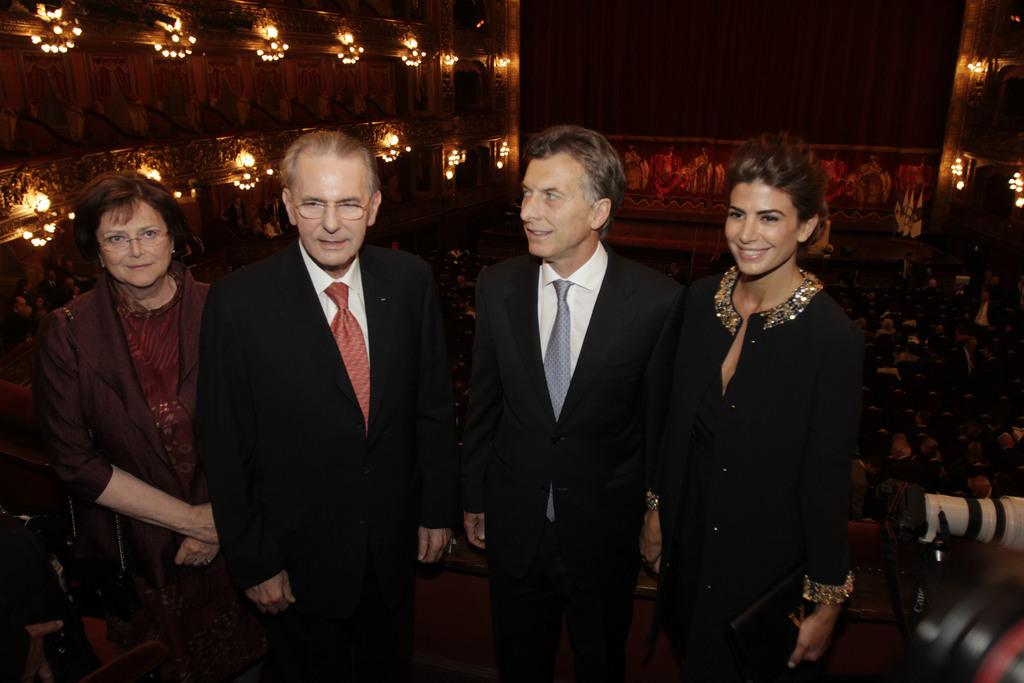How many people are present in the image? There are four people in the image, two women and two men. What are the people in the image doing? The people in the image are standing and smiling. Can you describe the people in the background of the image? There are people sitting in the background of the image. What can be seen in the image that provides light? The image contains lights. What type of jam is being spread on the bread in the image? There is no bread or jam present in the image; it features four people standing and smiling. Does the existence of the people in the image prove the existence of extraterrestrial life? The presence of people in the image does not prove the existence of extraterrestrial life, as the image only shows four individuals. 